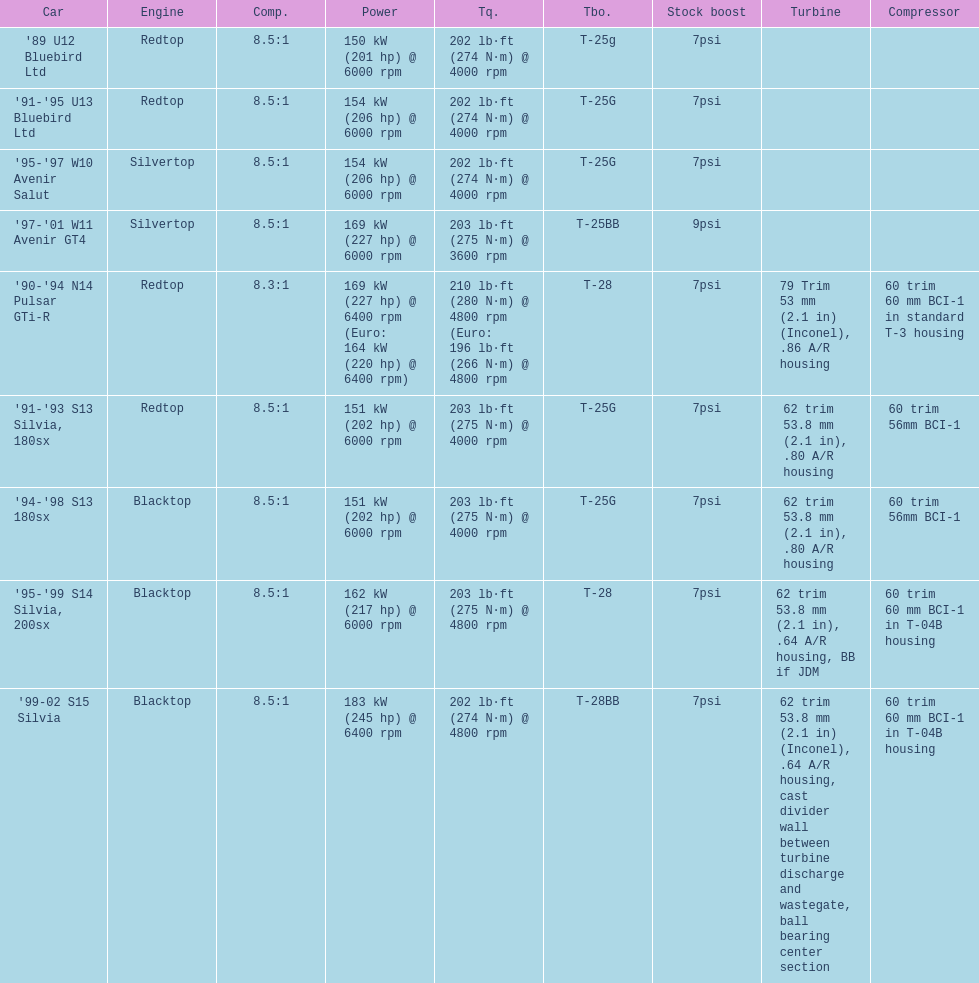Can you give me this table as a dict? {'header': ['Car', 'Engine', 'Comp.', 'Power', 'Tq.', 'Tbo.', 'Stock boost', 'Turbine', 'Compressor'], 'rows': [["'89 U12 Bluebird Ltd", 'Redtop', '8.5:1', '150\xa0kW (201\xa0hp) @ 6000 rpm', '202\xa0lb·ft (274\xa0N·m) @ 4000 rpm', 'T-25g', '7psi', '', ''], ["'91-'95 U13 Bluebird Ltd", 'Redtop', '8.5:1', '154\xa0kW (206\xa0hp) @ 6000 rpm', '202\xa0lb·ft (274\xa0N·m) @ 4000 rpm', 'T-25G', '7psi', '', ''], ["'95-'97 W10 Avenir Salut", 'Silvertop', '8.5:1', '154\xa0kW (206\xa0hp) @ 6000 rpm', '202\xa0lb·ft (274\xa0N·m) @ 4000 rpm', 'T-25G', '7psi', '', ''], ["'97-'01 W11 Avenir GT4", 'Silvertop', '8.5:1', '169\xa0kW (227\xa0hp) @ 6000 rpm', '203\xa0lb·ft (275\xa0N·m) @ 3600 rpm', 'T-25BB', '9psi', '', ''], ["'90-'94 N14 Pulsar GTi-R", 'Redtop', '8.3:1', '169\xa0kW (227\xa0hp) @ 6400 rpm (Euro: 164\xa0kW (220\xa0hp) @ 6400 rpm)', '210\xa0lb·ft (280\xa0N·m) @ 4800 rpm (Euro: 196\xa0lb·ft (266\xa0N·m) @ 4800 rpm', 'T-28', '7psi', '79 Trim 53\xa0mm (2.1\xa0in) (Inconel), .86 A/R housing', '60 trim 60\xa0mm BCI-1 in standard T-3 housing'], ["'91-'93 S13 Silvia, 180sx", 'Redtop', '8.5:1', '151\xa0kW (202\xa0hp) @ 6000 rpm', '203\xa0lb·ft (275\xa0N·m) @ 4000 rpm', 'T-25G', '7psi', '62 trim 53.8\xa0mm (2.1\xa0in), .80 A/R housing', '60 trim 56mm BCI-1'], ["'94-'98 S13 180sx", 'Blacktop', '8.5:1', '151\xa0kW (202\xa0hp) @ 6000 rpm', '203\xa0lb·ft (275\xa0N·m) @ 4000 rpm', 'T-25G', '7psi', '62 trim 53.8\xa0mm (2.1\xa0in), .80 A/R housing', '60 trim 56mm BCI-1'], ["'95-'99 S14 Silvia, 200sx", 'Blacktop', '8.5:1', '162\xa0kW (217\xa0hp) @ 6000 rpm', '203\xa0lb·ft (275\xa0N·m) @ 4800 rpm', 'T-28', '7psi', '62 trim 53.8\xa0mm (2.1\xa0in), .64 A/R housing, BB if JDM', '60 trim 60\xa0mm BCI-1 in T-04B housing'], ["'99-02 S15 Silvia", 'Blacktop', '8.5:1', '183\xa0kW (245\xa0hp) @ 6400 rpm', '202\xa0lb·ft (274\xa0N·m) @ 4800 rpm', 'T-28BB', '7psi', '62 trim 53.8\xa0mm (2.1\xa0in) (Inconel), .64 A/R housing, cast divider wall between turbine discharge and wastegate, ball bearing center section', '60 trim 60\xa0mm BCI-1 in T-04B housing']]} Which car is the only one with more than 230 hp? '99-02 S15 Silvia. 